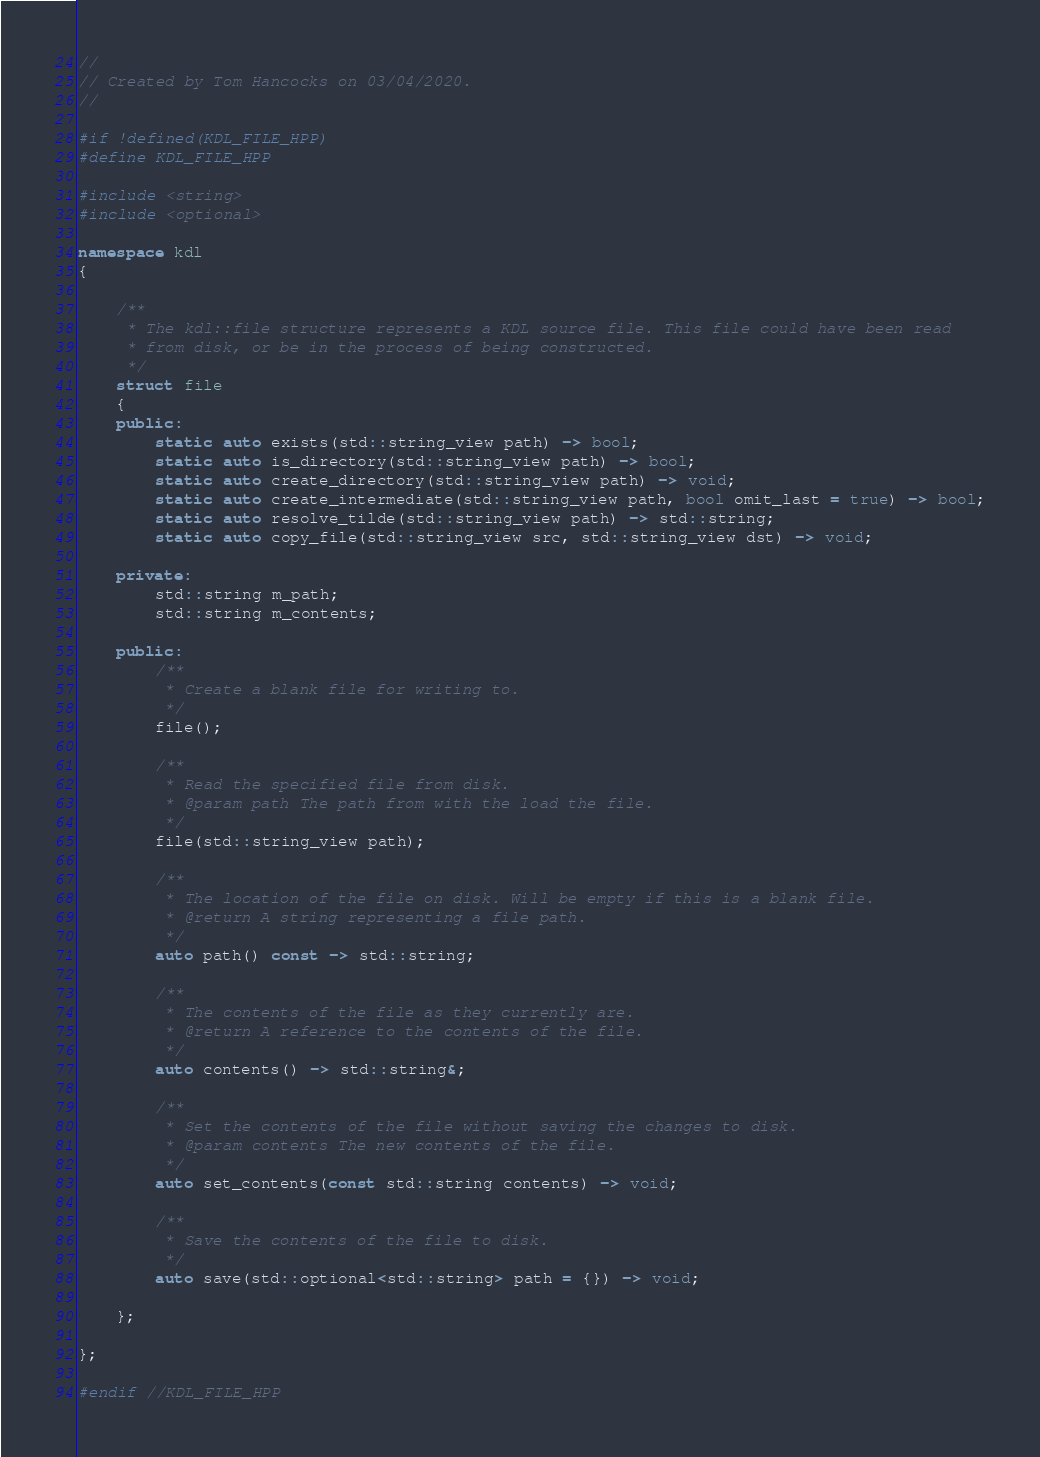Convert code to text. <code><loc_0><loc_0><loc_500><loc_500><_C++_>//
// Created by Tom Hancocks on 03/04/2020.
//

#if !defined(KDL_FILE_HPP)
#define KDL_FILE_HPP

#include <string>
#include <optional>

namespace kdl
{

    /**
     * The kdl::file structure represents a KDL source file. This file could have been read
     * from disk, or be in the process of being constructed.
     */
    struct file
    {
    public:
        static auto exists(std::string_view path) -> bool;
        static auto is_directory(std::string_view path) -> bool;
        static auto create_directory(std::string_view path) -> void;
        static auto create_intermediate(std::string_view path, bool omit_last = true) -> bool;
        static auto resolve_tilde(std::string_view path) -> std::string;
        static auto copy_file(std::string_view src, std::string_view dst) -> void;

    private:
        std::string m_path;
        std::string m_contents;

    public:
        /**
         * Create a blank file for writing to.
         */
        file();

        /**
         * Read the specified file from disk.
         * @param path The path from with the load the file.
         */
        file(std::string_view path);

        /**
         * The location of the file on disk. Will be empty if this is a blank file.
         * @return A string representing a file path.
         */
        auto path() const -> std::string;

        /**
         * The contents of the file as they currently are.
         * @return A reference to the contents of the file.
         */
        auto contents() -> std::string&;

        /**
         * Set the contents of the file without saving the changes to disk.
         * @param contents The new contents of the file.
         */
        auto set_contents(const std::string contents) -> void;

        /**
         * Save the contents of the file to disk.
         */
        auto save(std::optional<std::string> path = {}) -> void;

    };

};

#endif //KDL_FILE_HPP
</code> 